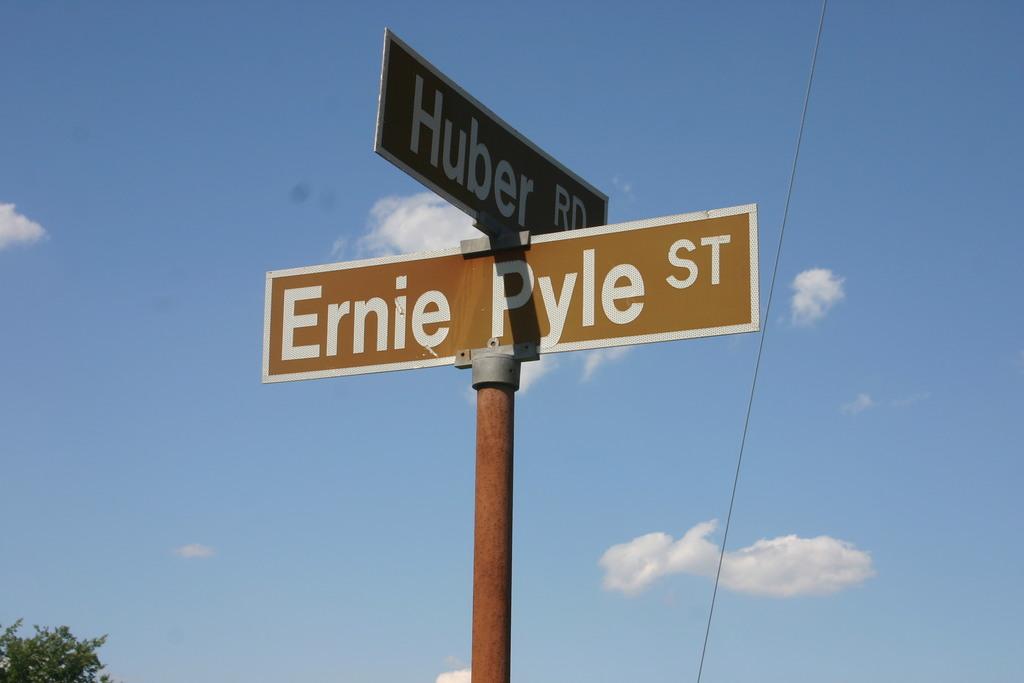What is the name of the road?
Your answer should be compact. Ernie pyle street. 